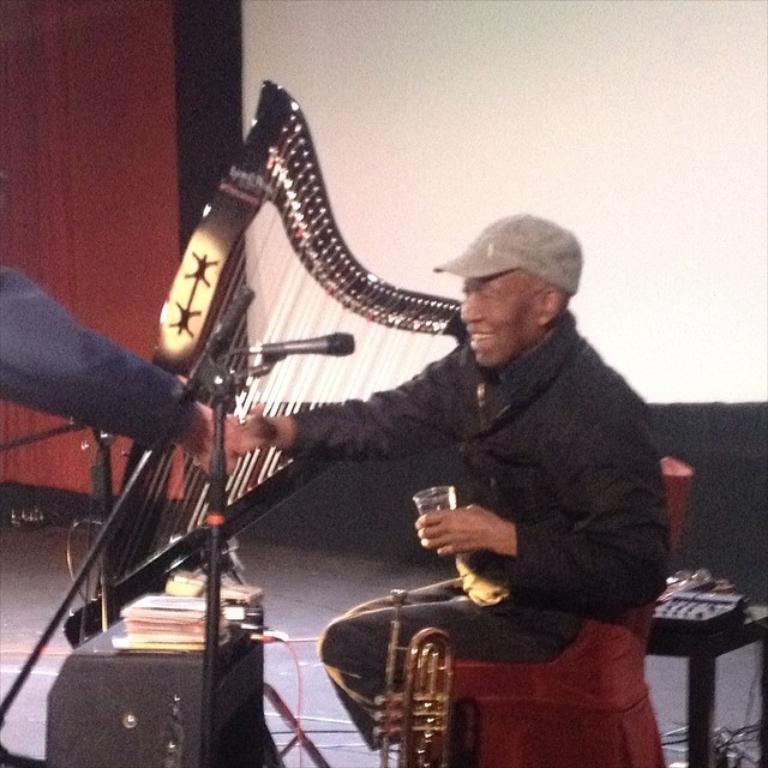Can you describe this image briefly? In the center of the picture there are musical instruments, cable, some books, stand, mic, a person holding glass and other objects. On the left we can see a person's hand. In the background it is wall and there is curtain also. 